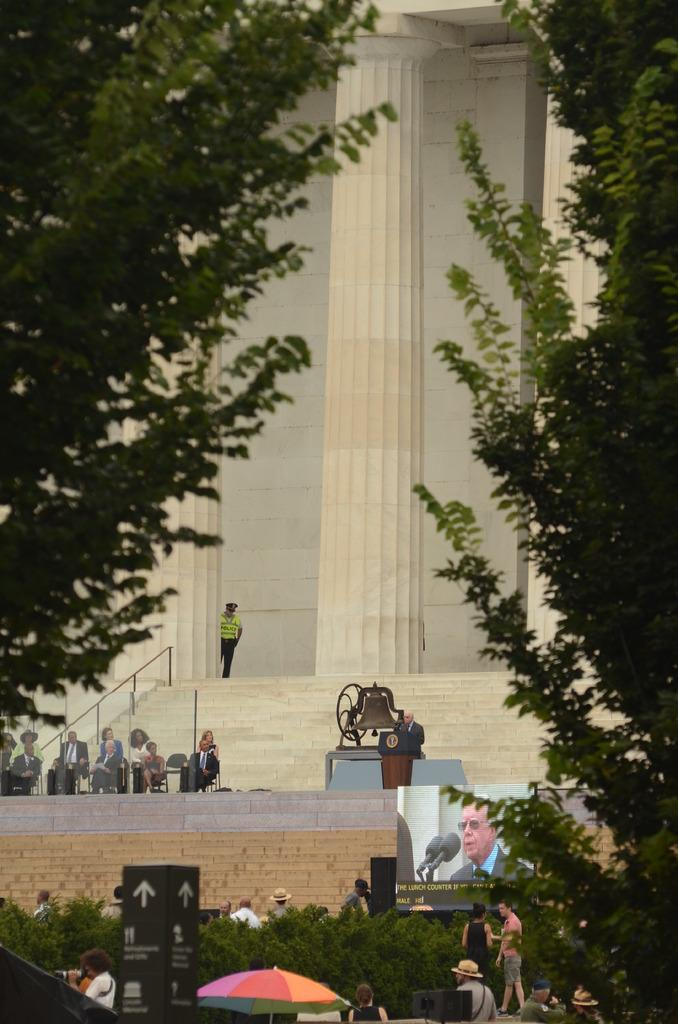What types of vegetation can be seen in the image? There are plants and trees in the image. What objects are made of wood in the image? There are boards in the image. What type of barrier is present in the image? There is a screen in the image. What protective item is visible in the image? There is an umbrella in the image. What type of sound-making object is present in the image? There is a bell in the image. How many persons are visible in the image? There are persons in the image. What architectural features can be seen in the background of the image? In the background, there are pillars and a wall. Can you describe the person in the background of the image? There is a person in the background of the image. Where is the crate located in the image? There is no crate present in the image. What type of wire is used to hold the bell in the image? There is no wire visible in the image, and the bell is not shown to be held by any wire. 